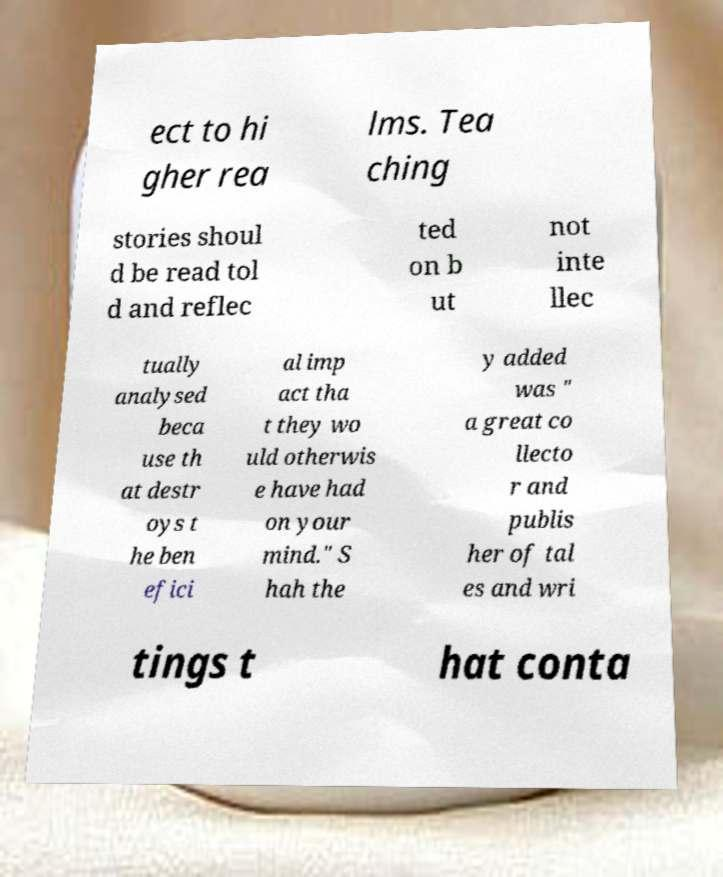Could you extract and type out the text from this image? ect to hi gher rea lms. Tea ching stories shoul d be read tol d and reflec ted on b ut not inte llec tually analysed beca use th at destr oys t he ben efici al imp act tha t they wo uld otherwis e have had on your mind." S hah the y added was " a great co llecto r and publis her of tal es and wri tings t hat conta 